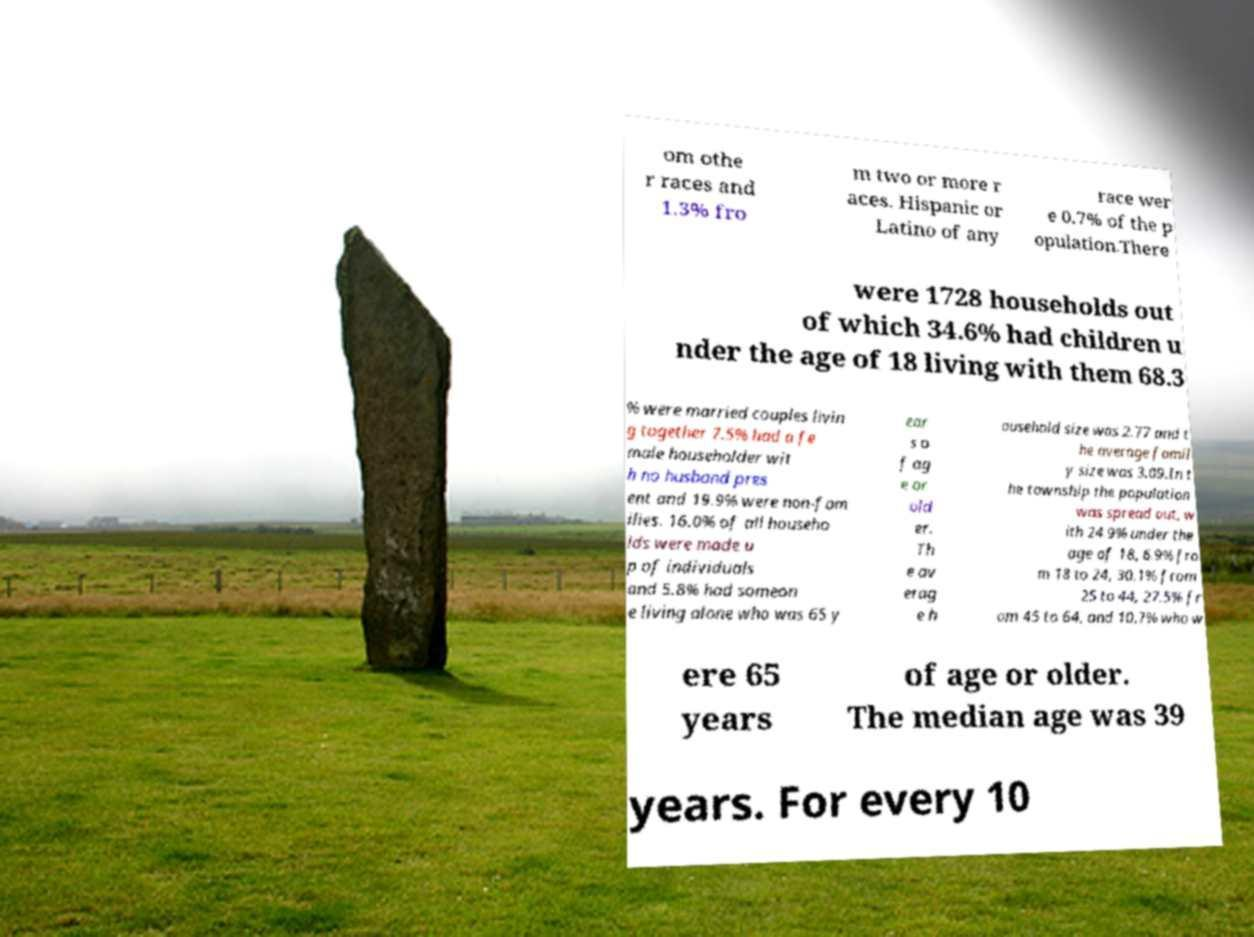Can you read and provide the text displayed in the image?This photo seems to have some interesting text. Can you extract and type it out for me? om othe r races and 1.3% fro m two or more r aces. Hispanic or Latino of any race wer e 0.7% of the p opulation.There were 1728 households out of which 34.6% had children u nder the age of 18 living with them 68.3 % were married couples livin g together 7.5% had a fe male householder wit h no husband pres ent and 19.9% were non-fam ilies. 16.0% of all househo lds were made u p of individuals and 5.8% had someon e living alone who was 65 y ear s o f ag e or old er. Th e av erag e h ousehold size was 2.77 and t he average famil y size was 3.09.In t he township the population was spread out, w ith 24.9% under the age of 18, 6.9% fro m 18 to 24, 30.1% from 25 to 44, 27.5% fr om 45 to 64, and 10.7% who w ere 65 years of age or older. The median age was 39 years. For every 10 